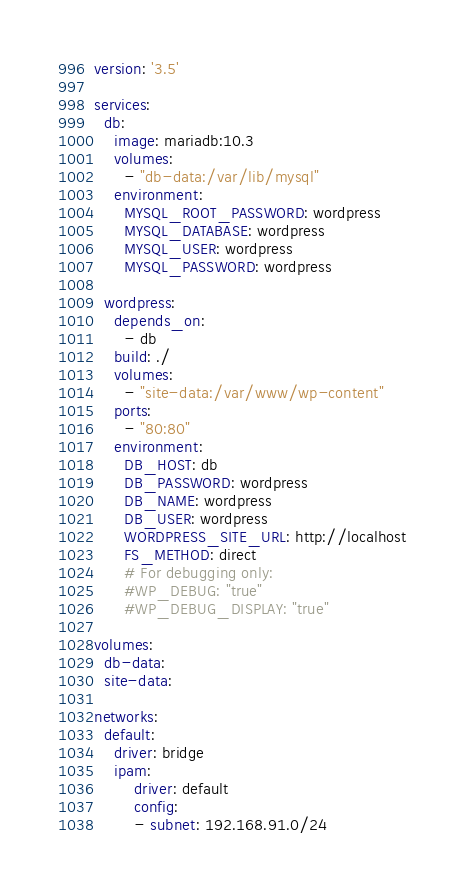<code> <loc_0><loc_0><loc_500><loc_500><_YAML_>version: '3.5'

services:
  db:
    image: mariadb:10.3
    volumes:
      - "db-data:/var/lib/mysql"
    environment:
      MYSQL_ROOT_PASSWORD: wordpress
      MYSQL_DATABASE: wordpress
      MYSQL_USER: wordpress
      MYSQL_PASSWORD: wordpress

  wordpress:
    depends_on:
      - db
    build: ./
    volumes:
      - "site-data:/var/www/wp-content"
    ports:
      - "80:80"
    environment:
      DB_HOST: db
      DB_PASSWORD: wordpress
      DB_NAME: wordpress
      DB_USER: wordpress
      WORDPRESS_SITE_URL: http://localhost
      FS_METHOD: direct
      # For debugging only:
      #WP_DEBUG: "true"
      #WP_DEBUG_DISPLAY: "true"

volumes:
  db-data:
  site-data:

networks:
  default:
    driver: bridge
    ipam:
        driver: default
        config:
        - subnet: 192.168.91.0/24
</code> 